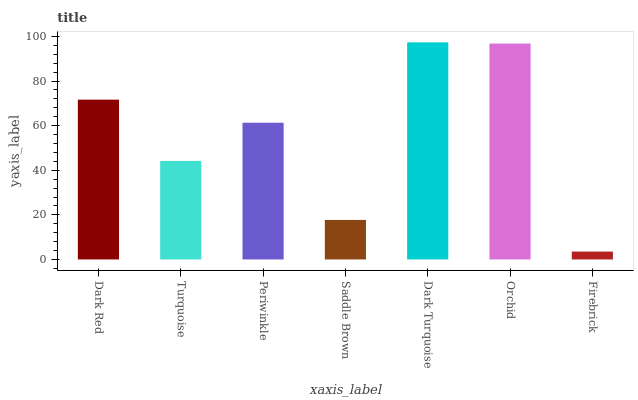Is Firebrick the minimum?
Answer yes or no. Yes. Is Dark Turquoise the maximum?
Answer yes or no. Yes. Is Turquoise the minimum?
Answer yes or no. No. Is Turquoise the maximum?
Answer yes or no. No. Is Dark Red greater than Turquoise?
Answer yes or no. Yes. Is Turquoise less than Dark Red?
Answer yes or no. Yes. Is Turquoise greater than Dark Red?
Answer yes or no. No. Is Dark Red less than Turquoise?
Answer yes or no. No. Is Periwinkle the high median?
Answer yes or no. Yes. Is Periwinkle the low median?
Answer yes or no. Yes. Is Dark Red the high median?
Answer yes or no. No. Is Dark Turquoise the low median?
Answer yes or no. No. 